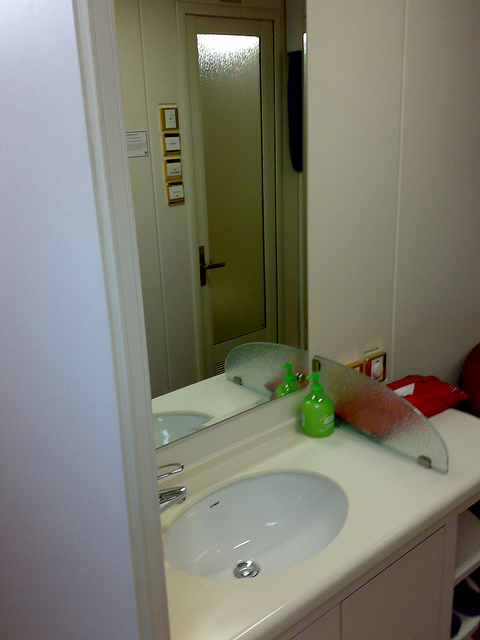<image>What does the sign on the wall mean? There is no sign on the wall in the image. What does the sign on the wall mean? I am not sure what the sign on the wall means. It can be 'privacy', 'art' or 'wash hands'. 